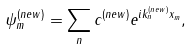Convert formula to latex. <formula><loc_0><loc_0><loc_500><loc_500>\psi ^ { ( n e w ) } _ { m } = \sum _ { n } c ^ { ( n e w ) } e ^ { i k ^ { ( n e w ) } _ { n } x _ { m } } ,</formula> 